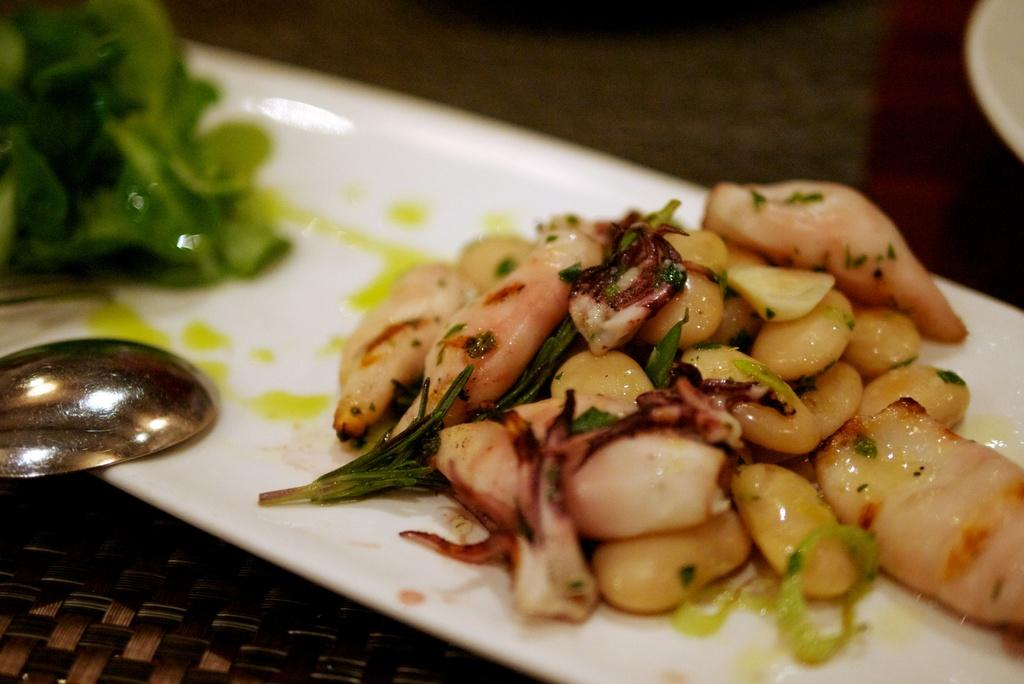What object is in the image that is used for holding items? There is a white tray in the image that is used for holding items. What is on the tray? The tray contains food, including leafy vegetables. What utensil is on the tray? There is a spoon on the tray. What is the color of the table the tray is placed on? The table is brown. How would you describe the background of the image? The background of the image is brown and blurred. What type of dress is being offered to the person in the image? There is no person or dress present in the image. What material is the wool used for in the image? There is no wool present in the image. 